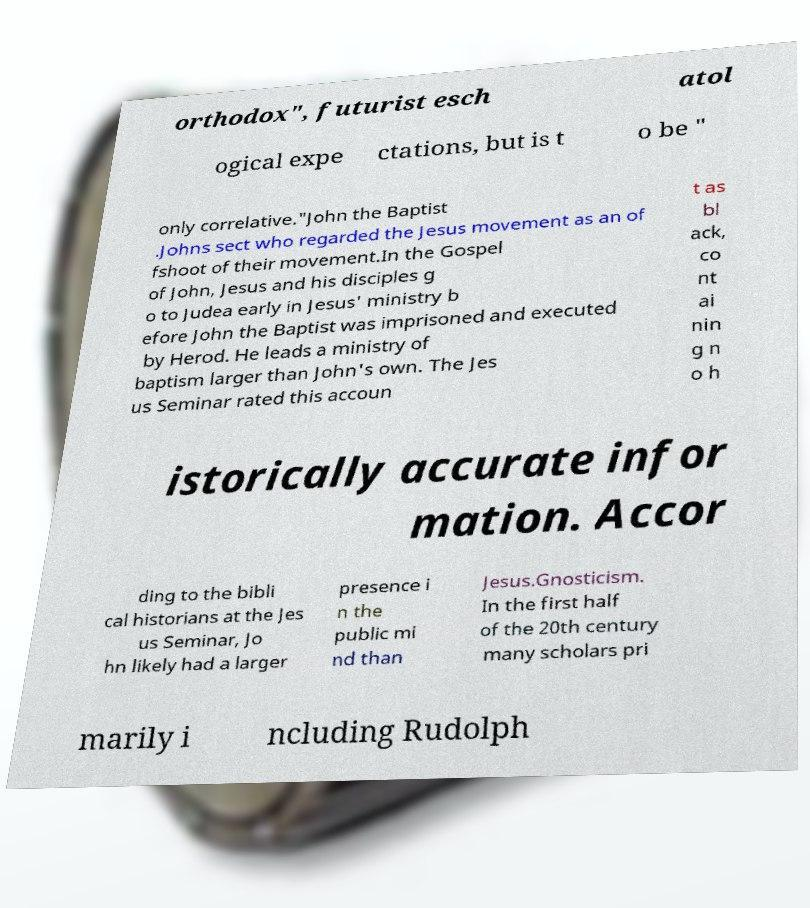For documentation purposes, I need the text within this image transcribed. Could you provide that? orthodox", futurist esch atol ogical expe ctations, but is t o be " only correlative."John the Baptist .Johns sect who regarded the Jesus movement as an of fshoot of their movement.In the Gospel of John, Jesus and his disciples g o to Judea early in Jesus' ministry b efore John the Baptist was imprisoned and executed by Herod. He leads a ministry of baptism larger than John's own. The Jes us Seminar rated this accoun t as bl ack, co nt ai nin g n o h istorically accurate infor mation. Accor ding to the bibli cal historians at the Jes us Seminar, Jo hn likely had a larger presence i n the public mi nd than Jesus.Gnosticism. In the first half of the 20th century many scholars pri marily i ncluding Rudolph 